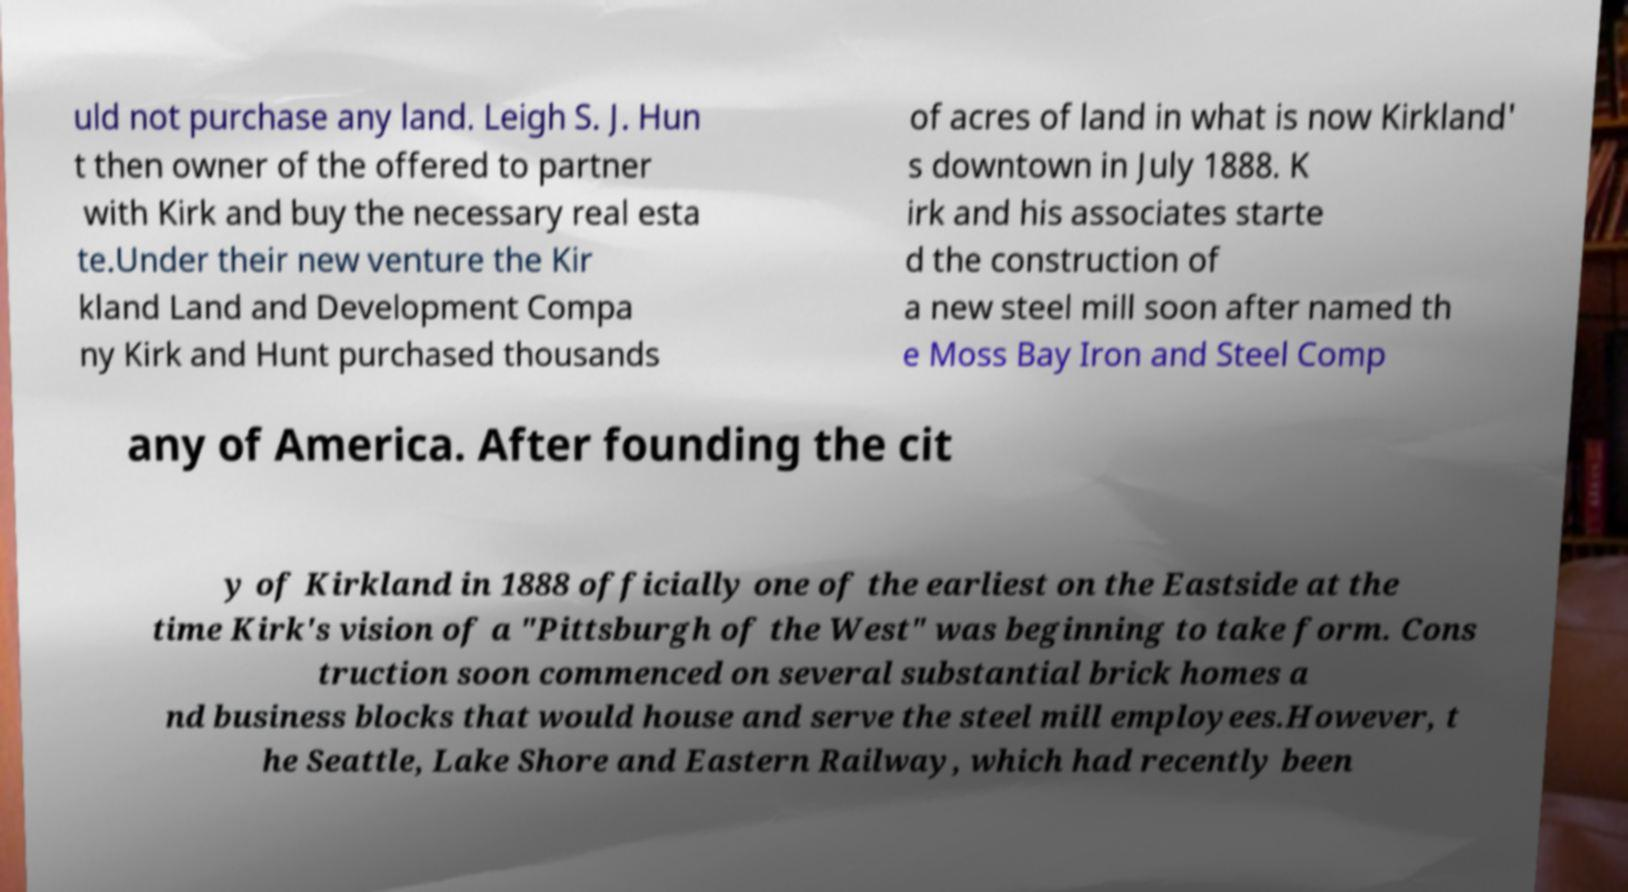Could you assist in decoding the text presented in this image and type it out clearly? uld not purchase any land. Leigh S. J. Hun t then owner of the offered to partner with Kirk and buy the necessary real esta te.Under their new venture the Kir kland Land and Development Compa ny Kirk and Hunt purchased thousands of acres of land in what is now Kirkland' s downtown in July 1888. K irk and his associates starte d the construction of a new steel mill soon after named th e Moss Bay Iron and Steel Comp any of America. After founding the cit y of Kirkland in 1888 officially one of the earliest on the Eastside at the time Kirk's vision of a "Pittsburgh of the West" was beginning to take form. Cons truction soon commenced on several substantial brick homes a nd business blocks that would house and serve the steel mill employees.However, t he Seattle, Lake Shore and Eastern Railway, which had recently been 